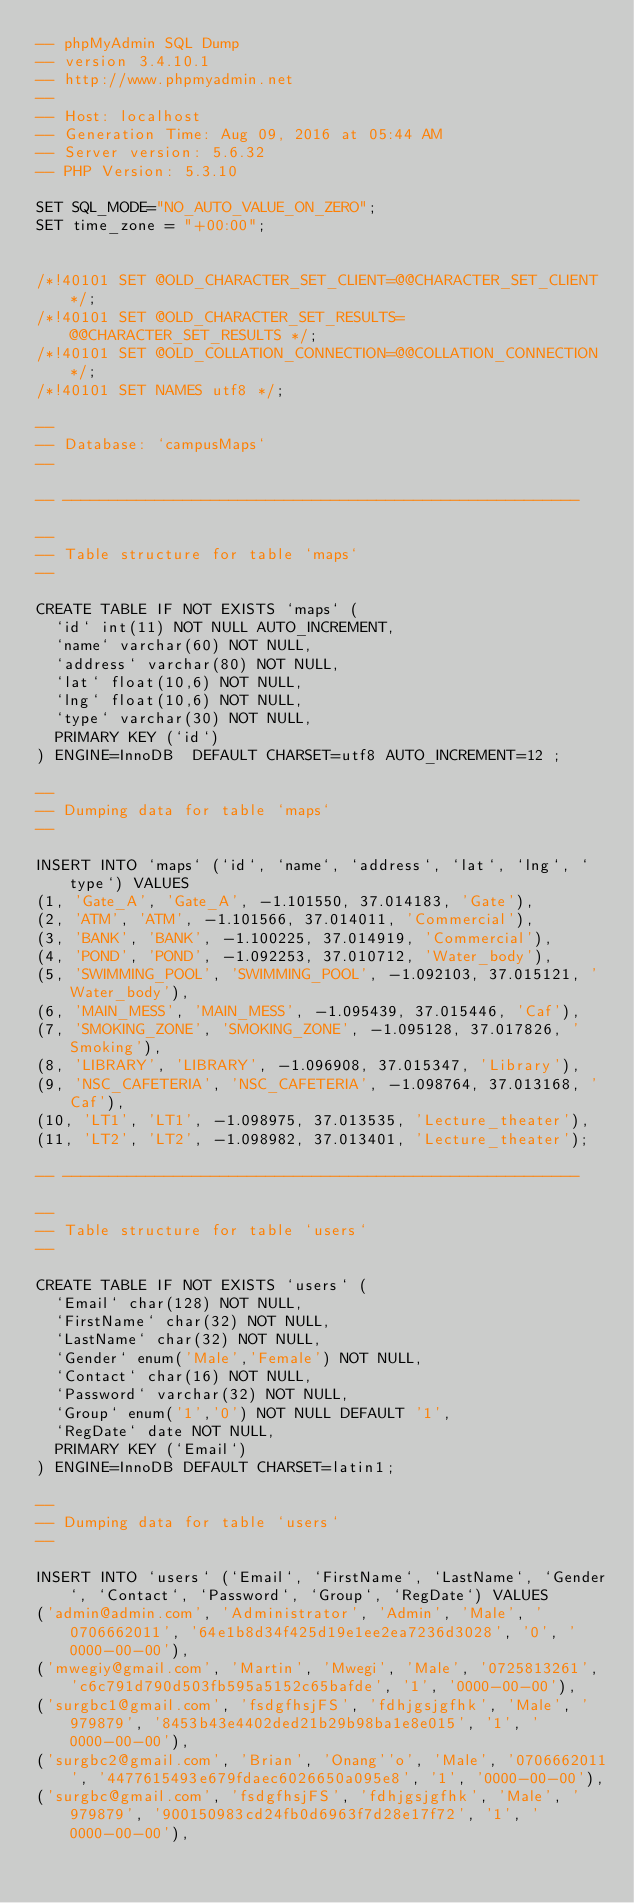Convert code to text. <code><loc_0><loc_0><loc_500><loc_500><_SQL_>-- phpMyAdmin SQL Dump
-- version 3.4.10.1
-- http://www.phpmyadmin.net
--
-- Host: localhost
-- Generation Time: Aug 09, 2016 at 05:44 AM
-- Server version: 5.6.32
-- PHP Version: 5.3.10

SET SQL_MODE="NO_AUTO_VALUE_ON_ZERO";
SET time_zone = "+00:00";


/*!40101 SET @OLD_CHARACTER_SET_CLIENT=@@CHARACTER_SET_CLIENT */;
/*!40101 SET @OLD_CHARACTER_SET_RESULTS=@@CHARACTER_SET_RESULTS */;
/*!40101 SET @OLD_COLLATION_CONNECTION=@@COLLATION_CONNECTION */;
/*!40101 SET NAMES utf8 */;

--
-- Database: `campusMaps`
--

-- --------------------------------------------------------

--
-- Table structure for table `maps`
--

CREATE TABLE IF NOT EXISTS `maps` (
  `id` int(11) NOT NULL AUTO_INCREMENT,
  `name` varchar(60) NOT NULL,
  `address` varchar(80) NOT NULL,
  `lat` float(10,6) NOT NULL,
  `lng` float(10,6) NOT NULL,
  `type` varchar(30) NOT NULL,
  PRIMARY KEY (`id`)
) ENGINE=InnoDB  DEFAULT CHARSET=utf8 AUTO_INCREMENT=12 ;

--
-- Dumping data for table `maps`
--

INSERT INTO `maps` (`id`, `name`, `address`, `lat`, `lng`, `type`) VALUES
(1, 'Gate_A', 'Gate_A', -1.101550, 37.014183, 'Gate'),
(2, 'ATM', 'ATM', -1.101566, 37.014011, 'Commercial'),
(3, 'BANK', 'BANK', -1.100225, 37.014919, 'Commercial'),
(4, 'POND', 'POND', -1.092253, 37.010712, 'Water_body'),
(5, 'SWIMMING_POOL', 'SWIMMING_POOL', -1.092103, 37.015121, 'Water_body'),
(6, 'MAIN_MESS', 'MAIN_MESS', -1.095439, 37.015446, 'Caf'),
(7, 'SMOKING_ZONE', 'SMOKING_ZONE', -1.095128, 37.017826, 'Smoking'),
(8, 'LIBRARY', 'LIBRARY', -1.096908, 37.015347, 'Library'),
(9, 'NSC_CAFETERIA', 'NSC_CAFETERIA', -1.098764, 37.013168, 'Caf'),
(10, 'LT1', 'LT1', -1.098975, 37.013535, 'Lecture_theater'),
(11, 'LT2', 'LT2', -1.098982, 37.013401, 'Lecture_theater');

-- --------------------------------------------------------

--
-- Table structure for table `users`
--

CREATE TABLE IF NOT EXISTS `users` (
  `Email` char(128) NOT NULL,
  `FirstName` char(32) NOT NULL,
  `LastName` char(32) NOT NULL,
  `Gender` enum('Male','Female') NOT NULL,
  `Contact` char(16) NOT NULL,
  `Password` varchar(32) NOT NULL,
  `Group` enum('1','0') NOT NULL DEFAULT '1',
  `RegDate` date NOT NULL,
  PRIMARY KEY (`Email`)
) ENGINE=InnoDB DEFAULT CHARSET=latin1;

--
-- Dumping data for table `users`
--

INSERT INTO `users` (`Email`, `FirstName`, `LastName`, `Gender`, `Contact`, `Password`, `Group`, `RegDate`) VALUES
('admin@admin.com', 'Administrator', 'Admin', 'Male', '0706662011', '64e1b8d34f425d19e1ee2ea7236d3028', '0', '0000-00-00'),
('mwegiy@gmail.com', 'Martin', 'Mwegi', 'Male', '0725813261', 'c6c791d790d503fb595a5152c65bafde', '1', '0000-00-00'),
('surgbc1@gmail.com', 'fsdgfhsjFS', 'fdhjgsjgfhk', 'Male', '979879', '8453b43e4402ded21b29b98ba1e8e015', '1', '0000-00-00'),
('surgbc2@gmail.com', 'Brian', 'Onang''o', 'Male', '0706662011', '4477615493e679fdaec6026650a095e8', '1', '0000-00-00'),
('surgbc@gmail.com', 'fsdgfhsjFS', 'fdhjgsjgfhk', 'Male', '979879', '900150983cd24fb0d6963f7d28e17f72', '1', '0000-00-00'),</code> 